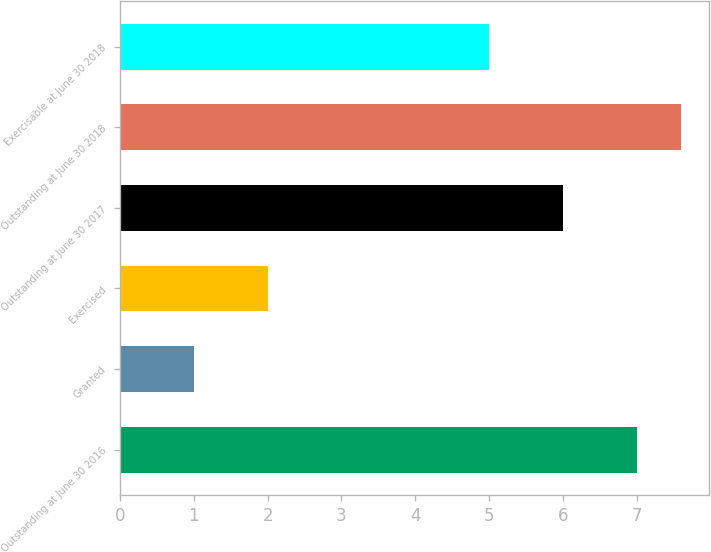<chart> <loc_0><loc_0><loc_500><loc_500><bar_chart><fcel>Outstanding at June 30 2016<fcel>Granted<fcel>Exercised<fcel>Outstanding at June 30 2017<fcel>Outstanding at June 30 2018<fcel>Exercisable at June 30 2018<nl><fcel>7<fcel>1<fcel>2<fcel>6<fcel>7.6<fcel>5<nl></chart> 